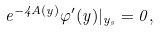<formula> <loc_0><loc_0><loc_500><loc_500>e ^ { - 4 A ( y ) } \varphi ^ { \prime } ( y ) | _ { y _ { s } } = 0 ,</formula> 